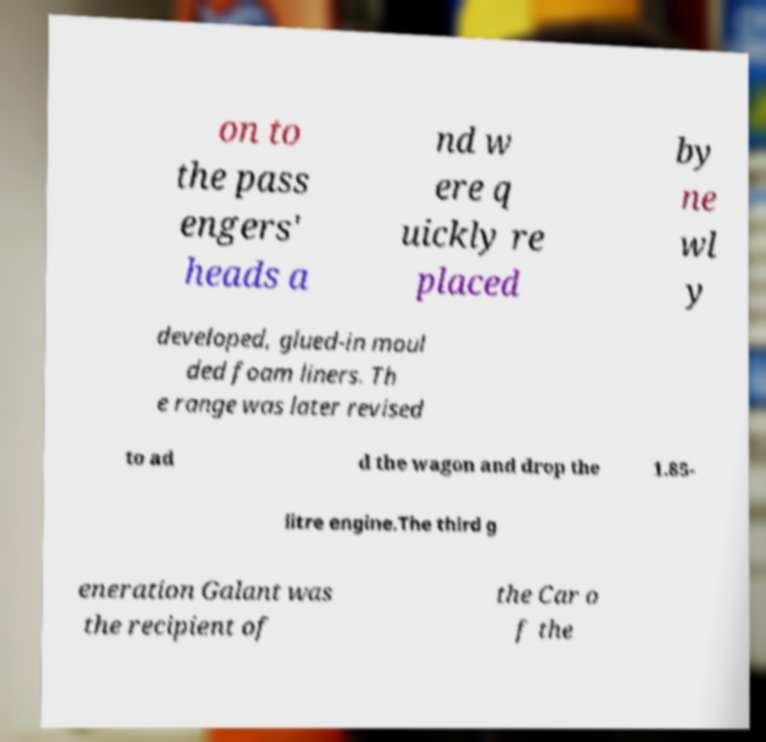Could you assist in decoding the text presented in this image and type it out clearly? on to the pass engers' heads a nd w ere q uickly re placed by ne wl y developed, glued-in moul ded foam liners. Th e range was later revised to ad d the wagon and drop the 1.85- litre engine.The third g eneration Galant was the recipient of the Car o f the 